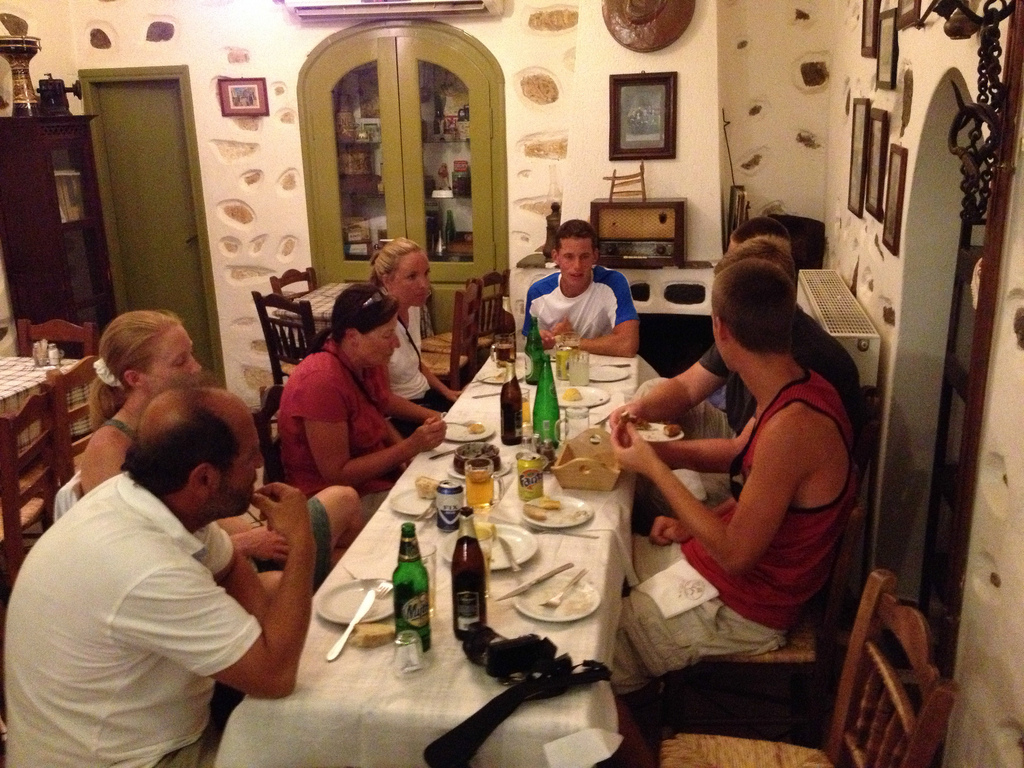Does the red shirt seem to be sitting? Yes, the individual in the red shirt is seated at the table, actively participating in the meal and conversation. 